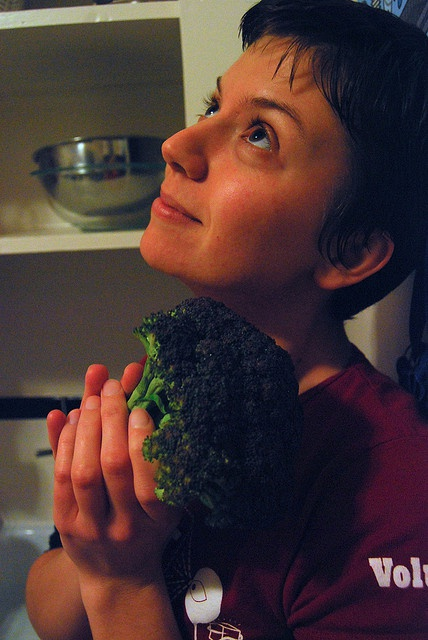Describe the objects in this image and their specific colors. I can see people in black, darkgreen, maroon, brown, and salmon tones, broccoli in darkgreen and black tones, and bowl in darkgreen, black, and gray tones in this image. 